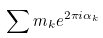Convert formula to latex. <formula><loc_0><loc_0><loc_500><loc_500>\sum m _ { k } e ^ { 2 \pi i \alpha _ { k } }</formula> 